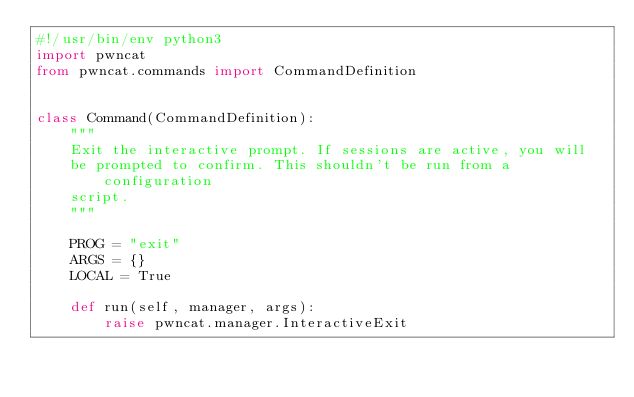<code> <loc_0><loc_0><loc_500><loc_500><_Python_>#!/usr/bin/env python3
import pwncat
from pwncat.commands import CommandDefinition


class Command(CommandDefinition):
    """
    Exit the interactive prompt. If sessions are active, you will
    be prompted to confirm. This shouldn't be run from a configuration
    script.
    """

    PROG = "exit"
    ARGS = {}
    LOCAL = True

    def run(self, manager, args):
        raise pwncat.manager.InteractiveExit
</code> 